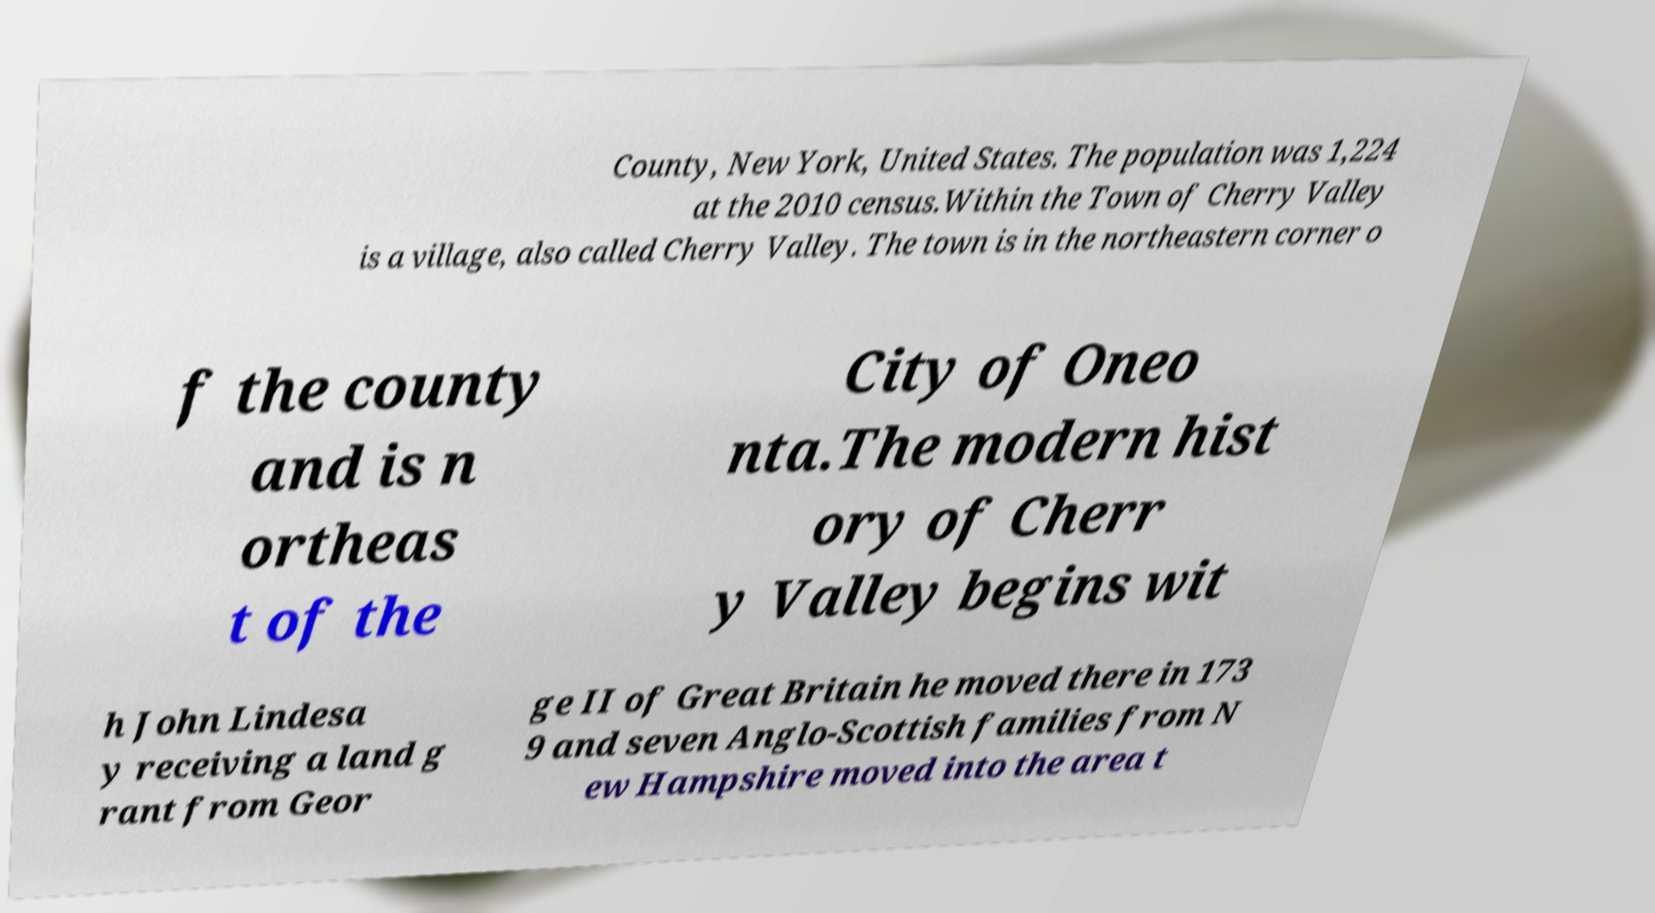Please read and relay the text visible in this image. What does it say? County, New York, United States. The population was 1,224 at the 2010 census.Within the Town of Cherry Valley is a village, also called Cherry Valley. The town is in the northeastern corner o f the county and is n ortheas t of the City of Oneo nta.The modern hist ory of Cherr y Valley begins wit h John Lindesa y receiving a land g rant from Geor ge II of Great Britain he moved there in 173 9 and seven Anglo-Scottish families from N ew Hampshire moved into the area t 